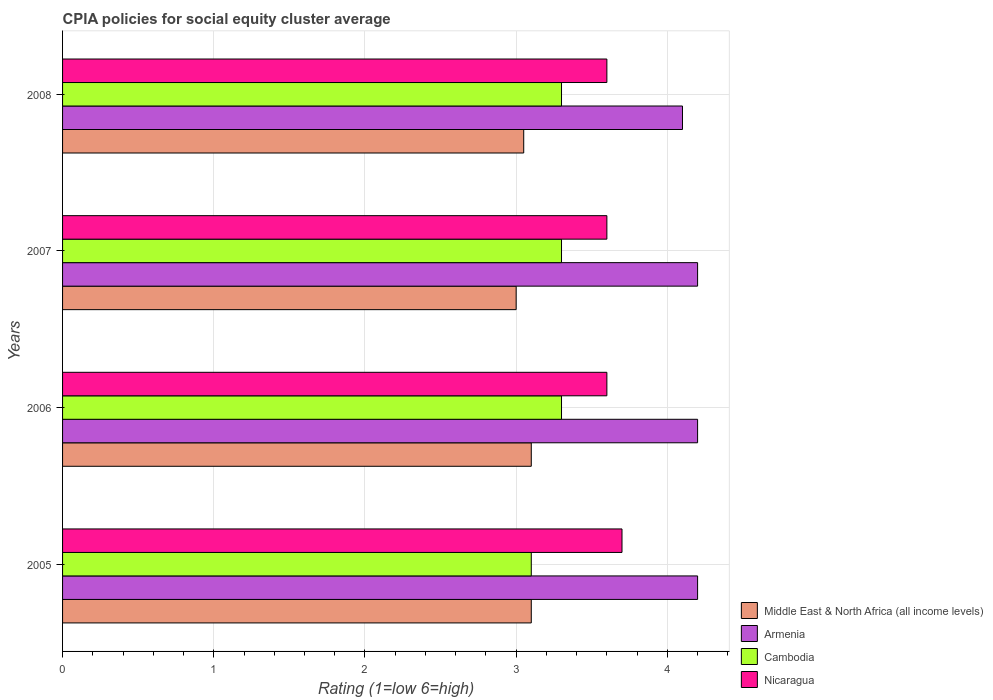Are the number of bars per tick equal to the number of legend labels?
Provide a short and direct response. Yes. Are the number of bars on each tick of the Y-axis equal?
Provide a short and direct response. Yes. How many bars are there on the 4th tick from the top?
Ensure brevity in your answer.  4. What is the CPIA rating in Cambodia in 2007?
Make the answer very short. 3.3. Across all years, what is the minimum CPIA rating in Nicaragua?
Offer a very short reply. 3.6. In which year was the CPIA rating in Armenia maximum?
Ensure brevity in your answer.  2005. In which year was the CPIA rating in Nicaragua minimum?
Provide a succinct answer. 2006. Is the difference between the CPIA rating in Middle East & North Africa (all income levels) in 2007 and 2008 greater than the difference between the CPIA rating in Armenia in 2007 and 2008?
Your answer should be very brief. No. What is the difference between the highest and the lowest CPIA rating in Armenia?
Your answer should be very brief. 0.1. In how many years, is the CPIA rating in Middle East & North Africa (all income levels) greater than the average CPIA rating in Middle East & North Africa (all income levels) taken over all years?
Make the answer very short. 2. Is the sum of the CPIA rating in Cambodia in 2005 and 2007 greater than the maximum CPIA rating in Middle East & North Africa (all income levels) across all years?
Make the answer very short. Yes. What does the 2nd bar from the top in 2006 represents?
Keep it short and to the point. Cambodia. What does the 1st bar from the bottom in 2006 represents?
Your response must be concise. Middle East & North Africa (all income levels). Is it the case that in every year, the sum of the CPIA rating in Cambodia and CPIA rating in Middle East & North Africa (all income levels) is greater than the CPIA rating in Nicaragua?
Offer a terse response. Yes. What is the difference between two consecutive major ticks on the X-axis?
Offer a terse response. 1. Does the graph contain grids?
Your answer should be very brief. Yes. How are the legend labels stacked?
Give a very brief answer. Vertical. What is the title of the graph?
Offer a terse response. CPIA policies for social equity cluster average. Does "Djibouti" appear as one of the legend labels in the graph?
Offer a very short reply. No. What is the label or title of the Y-axis?
Offer a very short reply. Years. What is the Rating (1=low 6=high) in Middle East & North Africa (all income levels) in 2005?
Provide a succinct answer. 3.1. What is the Rating (1=low 6=high) of Middle East & North Africa (all income levels) in 2006?
Ensure brevity in your answer.  3.1. What is the Rating (1=low 6=high) of Armenia in 2006?
Offer a terse response. 4.2. What is the Rating (1=low 6=high) of Cambodia in 2006?
Give a very brief answer. 3.3. What is the Rating (1=low 6=high) of Nicaragua in 2006?
Your response must be concise. 3.6. What is the Rating (1=low 6=high) of Armenia in 2007?
Keep it short and to the point. 4.2. What is the Rating (1=low 6=high) of Cambodia in 2007?
Offer a very short reply. 3.3. What is the Rating (1=low 6=high) of Middle East & North Africa (all income levels) in 2008?
Offer a terse response. 3.05. What is the Rating (1=low 6=high) of Armenia in 2008?
Your answer should be very brief. 4.1. What is the Rating (1=low 6=high) of Cambodia in 2008?
Keep it short and to the point. 3.3. What is the Rating (1=low 6=high) in Nicaragua in 2008?
Your answer should be very brief. 3.6. Across all years, what is the maximum Rating (1=low 6=high) in Armenia?
Ensure brevity in your answer.  4.2. Across all years, what is the minimum Rating (1=low 6=high) in Armenia?
Your answer should be compact. 4.1. Across all years, what is the minimum Rating (1=low 6=high) in Nicaragua?
Your answer should be very brief. 3.6. What is the total Rating (1=low 6=high) in Middle East & North Africa (all income levels) in the graph?
Your response must be concise. 12.25. What is the total Rating (1=low 6=high) in Armenia in the graph?
Keep it short and to the point. 16.7. What is the total Rating (1=low 6=high) in Cambodia in the graph?
Your answer should be very brief. 13. What is the total Rating (1=low 6=high) of Nicaragua in the graph?
Make the answer very short. 14.5. What is the difference between the Rating (1=low 6=high) in Middle East & North Africa (all income levels) in 2005 and that in 2006?
Your answer should be compact. 0. What is the difference between the Rating (1=low 6=high) in Armenia in 2005 and that in 2006?
Your response must be concise. 0. What is the difference between the Rating (1=low 6=high) of Cambodia in 2005 and that in 2006?
Give a very brief answer. -0.2. What is the difference between the Rating (1=low 6=high) of Armenia in 2005 and that in 2007?
Offer a terse response. 0. What is the difference between the Rating (1=low 6=high) of Cambodia in 2005 and that in 2008?
Provide a short and direct response. -0.2. What is the difference between the Rating (1=low 6=high) of Middle East & North Africa (all income levels) in 2006 and that in 2007?
Make the answer very short. 0.1. What is the difference between the Rating (1=low 6=high) of Cambodia in 2006 and that in 2007?
Offer a terse response. 0. What is the difference between the Rating (1=low 6=high) of Middle East & North Africa (all income levels) in 2007 and that in 2008?
Ensure brevity in your answer.  -0.05. What is the difference between the Rating (1=low 6=high) in Middle East & North Africa (all income levels) in 2005 and the Rating (1=low 6=high) in Cambodia in 2006?
Provide a short and direct response. -0.2. What is the difference between the Rating (1=low 6=high) of Middle East & North Africa (all income levels) in 2005 and the Rating (1=low 6=high) of Nicaragua in 2006?
Keep it short and to the point. -0.5. What is the difference between the Rating (1=low 6=high) of Armenia in 2005 and the Rating (1=low 6=high) of Cambodia in 2006?
Provide a short and direct response. 0.9. What is the difference between the Rating (1=low 6=high) of Middle East & North Africa (all income levels) in 2005 and the Rating (1=low 6=high) of Cambodia in 2007?
Offer a terse response. -0.2. What is the difference between the Rating (1=low 6=high) in Middle East & North Africa (all income levels) in 2005 and the Rating (1=low 6=high) in Nicaragua in 2007?
Provide a short and direct response. -0.5. What is the difference between the Rating (1=low 6=high) in Armenia in 2005 and the Rating (1=low 6=high) in Cambodia in 2007?
Your answer should be compact. 0.9. What is the difference between the Rating (1=low 6=high) in Armenia in 2005 and the Rating (1=low 6=high) in Nicaragua in 2007?
Provide a short and direct response. 0.6. What is the difference between the Rating (1=low 6=high) in Middle East & North Africa (all income levels) in 2005 and the Rating (1=low 6=high) in Cambodia in 2008?
Offer a very short reply. -0.2. What is the difference between the Rating (1=low 6=high) of Middle East & North Africa (all income levels) in 2005 and the Rating (1=low 6=high) of Nicaragua in 2008?
Your answer should be compact. -0.5. What is the difference between the Rating (1=low 6=high) in Armenia in 2005 and the Rating (1=low 6=high) in Nicaragua in 2008?
Your response must be concise. 0.6. What is the difference between the Rating (1=low 6=high) of Middle East & North Africa (all income levels) in 2006 and the Rating (1=low 6=high) of Armenia in 2007?
Give a very brief answer. -1.1. What is the difference between the Rating (1=low 6=high) in Middle East & North Africa (all income levels) in 2006 and the Rating (1=low 6=high) in Nicaragua in 2007?
Give a very brief answer. -0.5. What is the difference between the Rating (1=low 6=high) in Middle East & North Africa (all income levels) in 2006 and the Rating (1=low 6=high) in Armenia in 2008?
Make the answer very short. -1. What is the difference between the Rating (1=low 6=high) in Middle East & North Africa (all income levels) in 2006 and the Rating (1=low 6=high) in Cambodia in 2008?
Your answer should be very brief. -0.2. What is the difference between the Rating (1=low 6=high) of Cambodia in 2006 and the Rating (1=low 6=high) of Nicaragua in 2008?
Offer a terse response. -0.3. What is the difference between the Rating (1=low 6=high) of Middle East & North Africa (all income levels) in 2007 and the Rating (1=low 6=high) of Armenia in 2008?
Make the answer very short. -1.1. What is the difference between the Rating (1=low 6=high) of Armenia in 2007 and the Rating (1=low 6=high) of Cambodia in 2008?
Offer a terse response. 0.9. What is the difference between the Rating (1=low 6=high) in Armenia in 2007 and the Rating (1=low 6=high) in Nicaragua in 2008?
Provide a short and direct response. 0.6. What is the difference between the Rating (1=low 6=high) in Cambodia in 2007 and the Rating (1=low 6=high) in Nicaragua in 2008?
Provide a short and direct response. -0.3. What is the average Rating (1=low 6=high) in Middle East & North Africa (all income levels) per year?
Ensure brevity in your answer.  3.06. What is the average Rating (1=low 6=high) in Armenia per year?
Give a very brief answer. 4.17. What is the average Rating (1=low 6=high) of Nicaragua per year?
Provide a succinct answer. 3.62. In the year 2006, what is the difference between the Rating (1=low 6=high) of Armenia and Rating (1=low 6=high) of Cambodia?
Provide a succinct answer. 0.9. In the year 2006, what is the difference between the Rating (1=low 6=high) of Armenia and Rating (1=low 6=high) of Nicaragua?
Offer a terse response. 0.6. In the year 2007, what is the difference between the Rating (1=low 6=high) in Middle East & North Africa (all income levels) and Rating (1=low 6=high) in Armenia?
Your answer should be compact. -1.2. In the year 2007, what is the difference between the Rating (1=low 6=high) in Middle East & North Africa (all income levels) and Rating (1=low 6=high) in Nicaragua?
Your answer should be compact. -0.6. In the year 2007, what is the difference between the Rating (1=low 6=high) in Armenia and Rating (1=low 6=high) in Nicaragua?
Provide a short and direct response. 0.6. In the year 2008, what is the difference between the Rating (1=low 6=high) in Middle East & North Africa (all income levels) and Rating (1=low 6=high) in Armenia?
Provide a short and direct response. -1.05. In the year 2008, what is the difference between the Rating (1=low 6=high) of Middle East & North Africa (all income levels) and Rating (1=low 6=high) of Cambodia?
Ensure brevity in your answer.  -0.25. In the year 2008, what is the difference between the Rating (1=low 6=high) of Middle East & North Africa (all income levels) and Rating (1=low 6=high) of Nicaragua?
Your answer should be very brief. -0.55. What is the ratio of the Rating (1=low 6=high) in Armenia in 2005 to that in 2006?
Ensure brevity in your answer.  1. What is the ratio of the Rating (1=low 6=high) in Cambodia in 2005 to that in 2006?
Your answer should be compact. 0.94. What is the ratio of the Rating (1=low 6=high) in Nicaragua in 2005 to that in 2006?
Keep it short and to the point. 1.03. What is the ratio of the Rating (1=low 6=high) in Cambodia in 2005 to that in 2007?
Provide a short and direct response. 0.94. What is the ratio of the Rating (1=low 6=high) of Nicaragua in 2005 to that in 2007?
Ensure brevity in your answer.  1.03. What is the ratio of the Rating (1=low 6=high) in Middle East & North Africa (all income levels) in 2005 to that in 2008?
Provide a succinct answer. 1.02. What is the ratio of the Rating (1=low 6=high) of Armenia in 2005 to that in 2008?
Provide a short and direct response. 1.02. What is the ratio of the Rating (1=low 6=high) of Cambodia in 2005 to that in 2008?
Ensure brevity in your answer.  0.94. What is the ratio of the Rating (1=low 6=high) of Nicaragua in 2005 to that in 2008?
Your answer should be very brief. 1.03. What is the ratio of the Rating (1=low 6=high) of Armenia in 2006 to that in 2007?
Give a very brief answer. 1. What is the ratio of the Rating (1=low 6=high) of Nicaragua in 2006 to that in 2007?
Your answer should be very brief. 1. What is the ratio of the Rating (1=low 6=high) in Middle East & North Africa (all income levels) in 2006 to that in 2008?
Offer a terse response. 1.02. What is the ratio of the Rating (1=low 6=high) in Armenia in 2006 to that in 2008?
Your answer should be very brief. 1.02. What is the ratio of the Rating (1=low 6=high) in Middle East & North Africa (all income levels) in 2007 to that in 2008?
Your answer should be compact. 0.98. What is the ratio of the Rating (1=low 6=high) in Armenia in 2007 to that in 2008?
Give a very brief answer. 1.02. What is the difference between the highest and the second highest Rating (1=low 6=high) of Middle East & North Africa (all income levels)?
Your response must be concise. 0. What is the difference between the highest and the second highest Rating (1=low 6=high) of Armenia?
Your answer should be very brief. 0. What is the difference between the highest and the lowest Rating (1=low 6=high) in Middle East & North Africa (all income levels)?
Give a very brief answer. 0.1. What is the difference between the highest and the lowest Rating (1=low 6=high) in Armenia?
Give a very brief answer. 0.1. What is the difference between the highest and the lowest Rating (1=low 6=high) in Cambodia?
Your response must be concise. 0.2. 